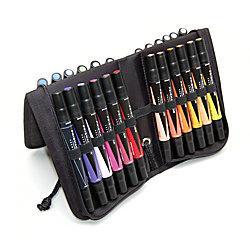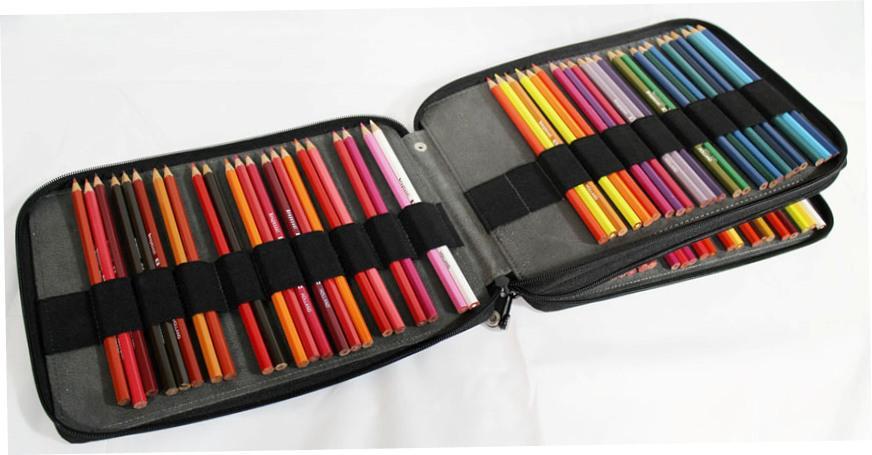The first image is the image on the left, the second image is the image on the right. Analyze the images presented: Is the assertion "One binder is displayed upright with its three filled sections fanned out and each section shorter than it is wide." valid? Answer yes or no. No. The first image is the image on the left, the second image is the image on the right. Considering the images on both sides, is "The cases in both images are currently storing only colored pencils." valid? Answer yes or no. No. 